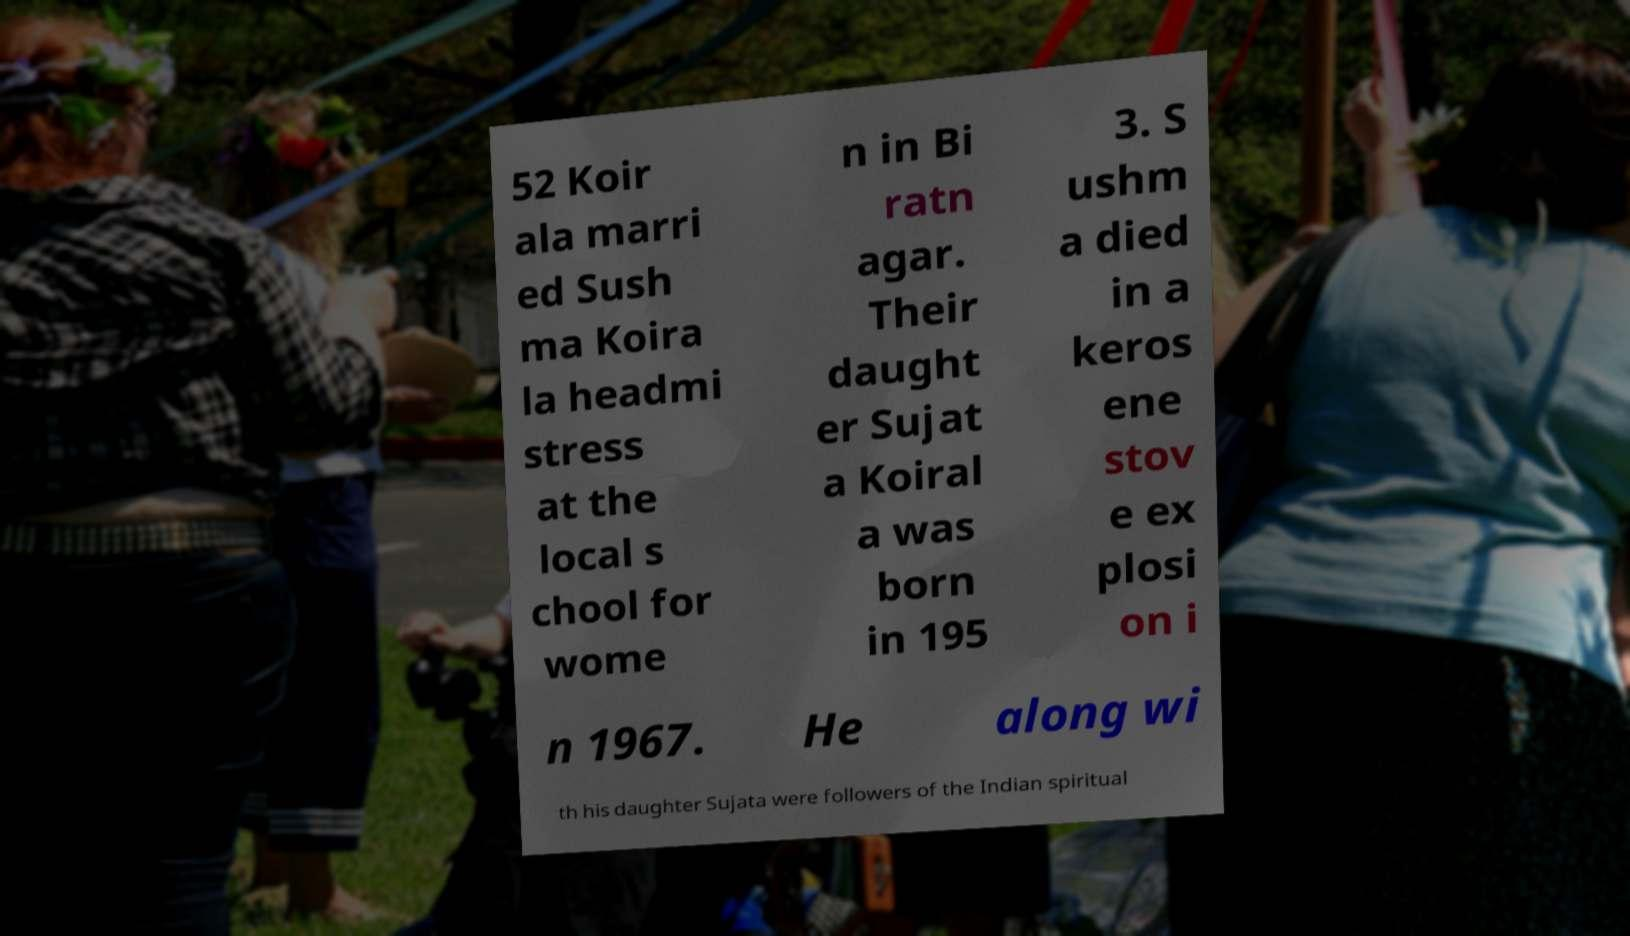I need the written content from this picture converted into text. Can you do that? 52 Koir ala marri ed Sush ma Koira la headmi stress at the local s chool for wome n in Bi ratn agar. Their daught er Sujat a Koiral a was born in 195 3. S ushm a died in a keros ene stov e ex plosi on i n 1967. He along wi th his daughter Sujata were followers of the Indian spiritual 